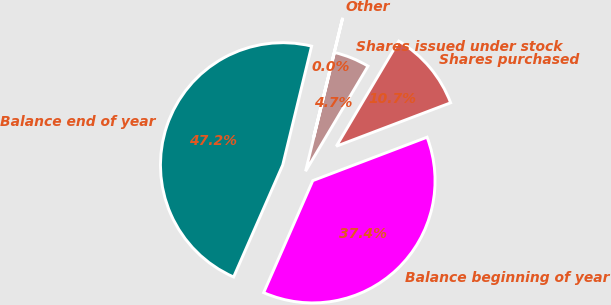Convert chart to OTSL. <chart><loc_0><loc_0><loc_500><loc_500><pie_chart><fcel>Balance beginning of year<fcel>Shares purchased<fcel>Shares issued under stock<fcel>Other<fcel>Balance end of year<nl><fcel>37.36%<fcel>10.69%<fcel>4.73%<fcel>0.01%<fcel>47.22%<nl></chart> 